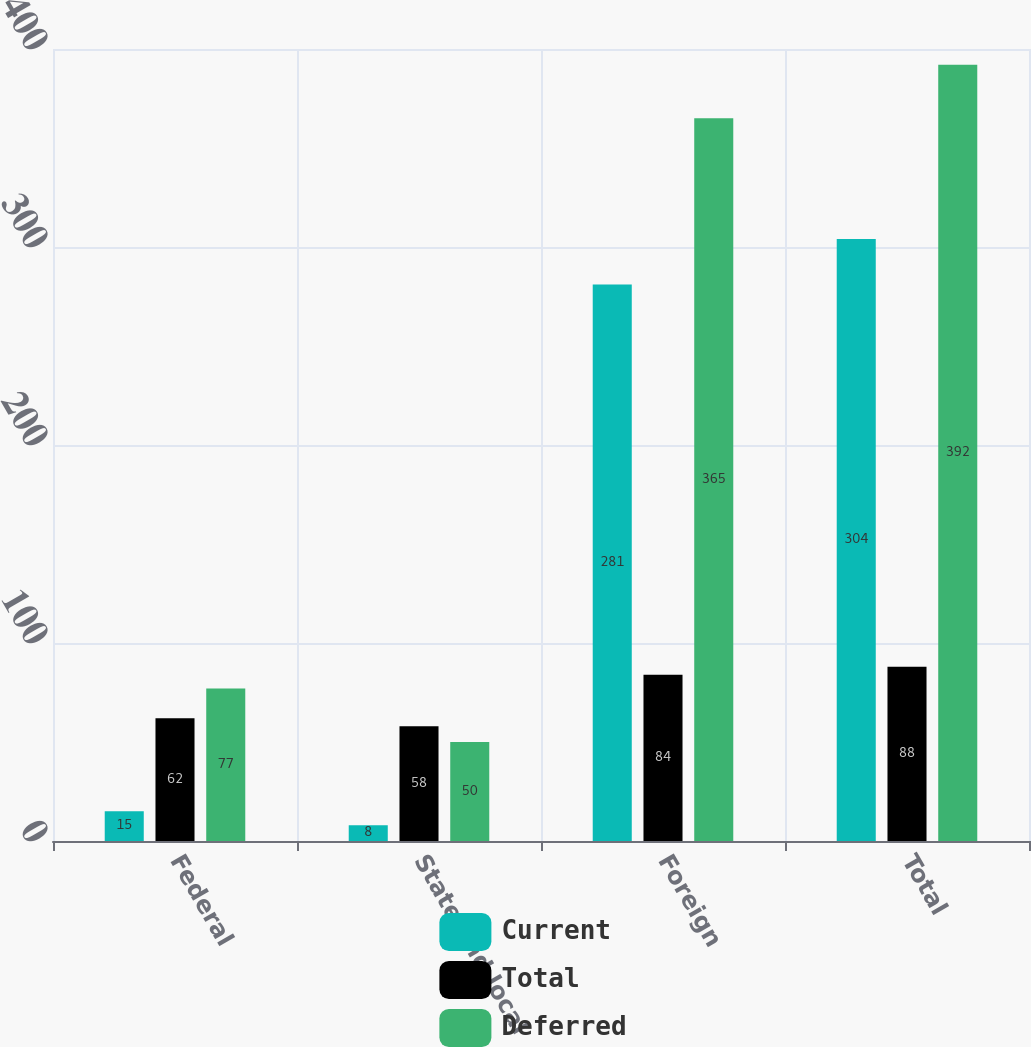Convert chart to OTSL. <chart><loc_0><loc_0><loc_500><loc_500><stacked_bar_chart><ecel><fcel>Federal<fcel>State and local<fcel>Foreign<fcel>Total<nl><fcel>Current<fcel>15<fcel>8<fcel>281<fcel>304<nl><fcel>Total<fcel>62<fcel>58<fcel>84<fcel>88<nl><fcel>Deferred<fcel>77<fcel>50<fcel>365<fcel>392<nl></chart> 